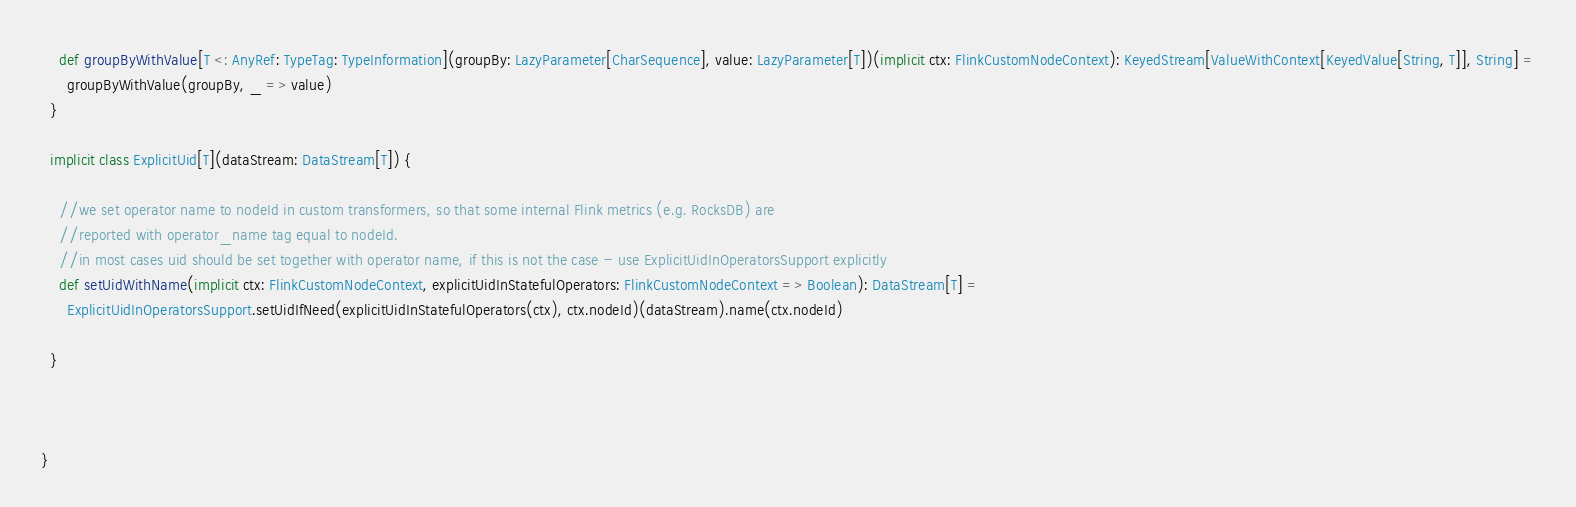Convert code to text. <code><loc_0><loc_0><loc_500><loc_500><_Scala_>    def groupByWithValue[T <: AnyRef: TypeTag: TypeInformation](groupBy: LazyParameter[CharSequence], value: LazyParameter[T])(implicit ctx: FlinkCustomNodeContext): KeyedStream[ValueWithContext[KeyedValue[String, T]], String] =
      groupByWithValue(groupBy, _ => value)
  }

  implicit class ExplicitUid[T](dataStream: DataStream[T]) {

    //we set operator name to nodeId in custom transformers, so that some internal Flink metrics (e.g. RocksDB) are
    //reported with operator_name tag equal to nodeId.
    //in most cases uid should be set together with operator name, if this is not the case - use ExplicitUidInOperatorsSupport explicitly
    def setUidWithName(implicit ctx: FlinkCustomNodeContext, explicitUidInStatefulOperators: FlinkCustomNodeContext => Boolean): DataStream[T] =
      ExplicitUidInOperatorsSupport.setUidIfNeed(explicitUidInStatefulOperators(ctx), ctx.nodeId)(dataStream).name(ctx.nodeId)

  }



}
</code> 